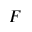<formula> <loc_0><loc_0><loc_500><loc_500>F</formula> 